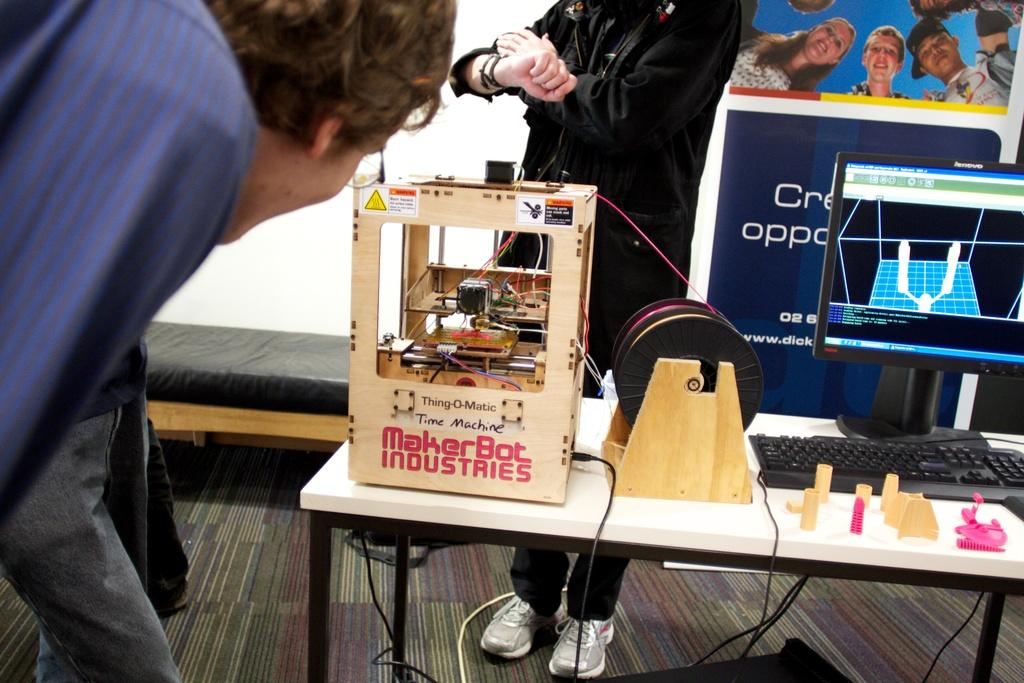What type of furniture is visible in the image? There is a desktop in the image. What is placed on the desktop? A keyboard is present on the desktop. What device can be seen on a table in the image? There is a 3D printer machine on a table. How many men are present in the image? There are two men standing beside the table, and one man is standing behind the table. What is hanging at the back of the scene? There is a banner at the back of the scene. What type of clothing is the man wearing to protect himself from the summer heat in the image? The image does not provide information about the weather or the man's clothing, so we cannot determine if he is wearing anything to protect himself from the summer heat. 